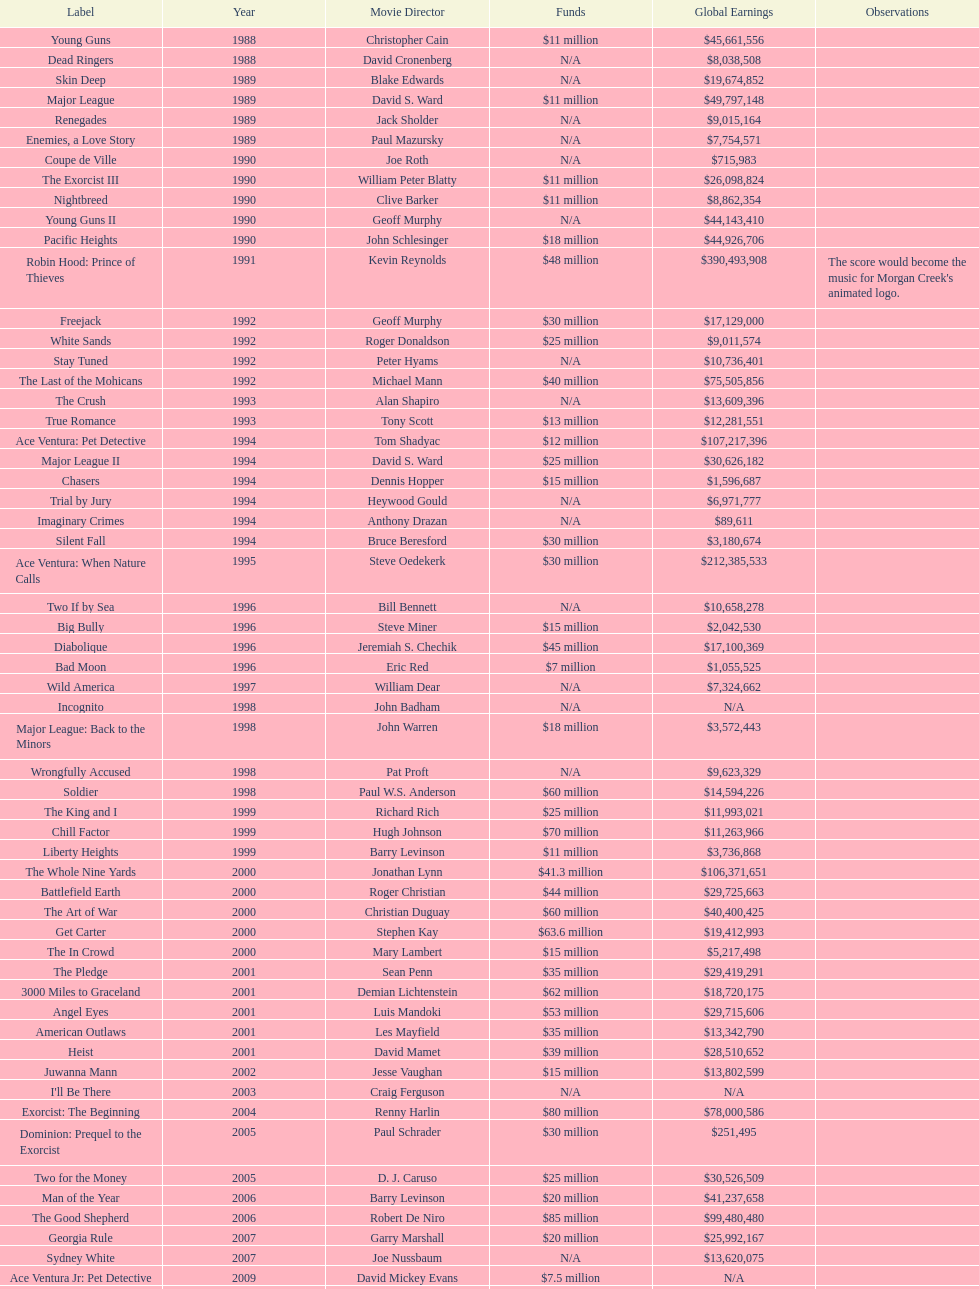What was the only movie with a 48 million dollar budget? Robin Hood: Prince of Thieves. 